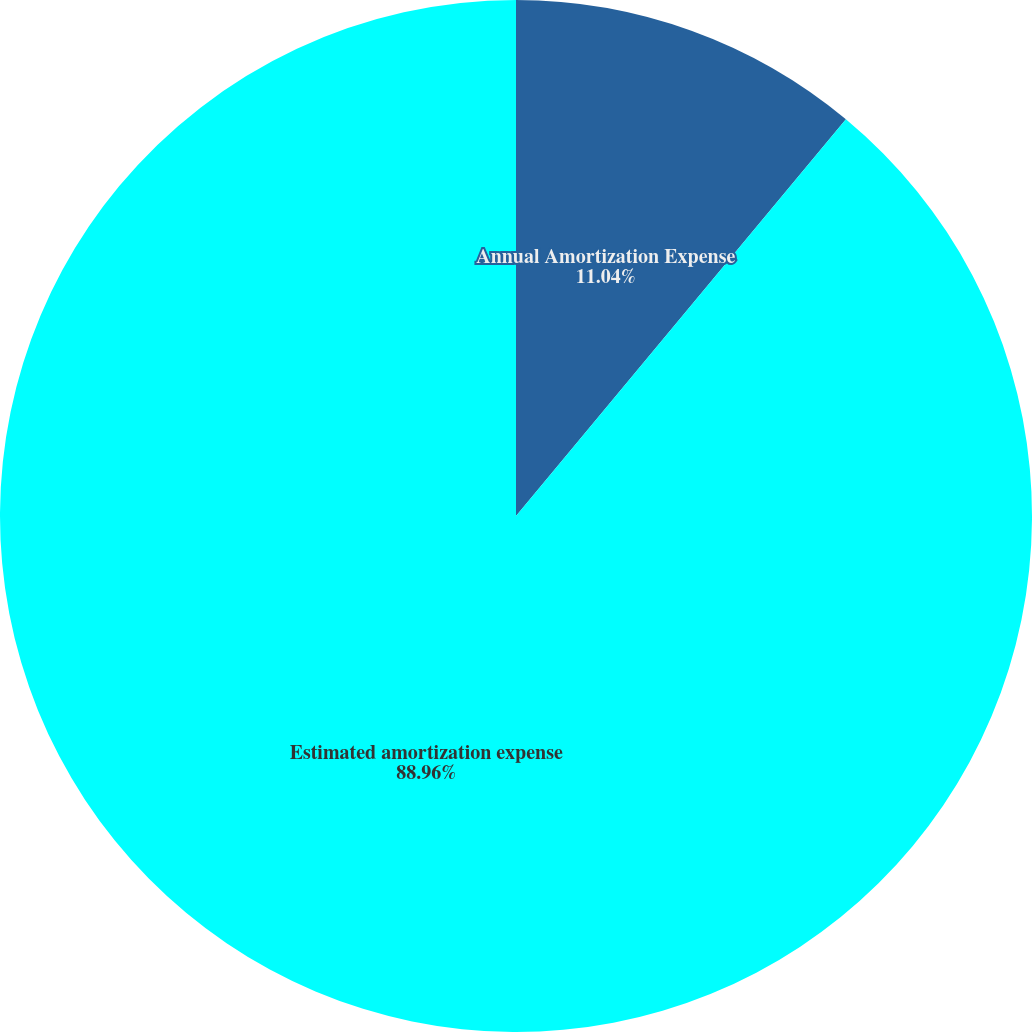Convert chart to OTSL. <chart><loc_0><loc_0><loc_500><loc_500><pie_chart><fcel>Annual Amortization Expense<fcel>Estimated amortization expense<nl><fcel>11.04%<fcel>88.96%<nl></chart> 